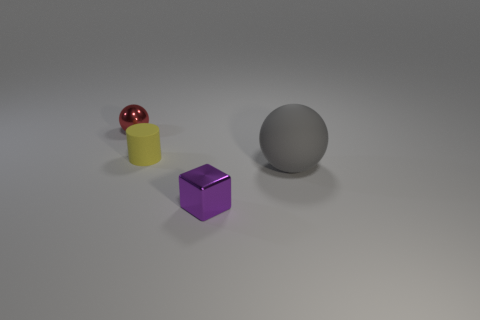What is the color of the metallic ball that is the same size as the yellow matte cylinder?
Your answer should be very brief. Red. There is a metallic thing in front of the tiny metal object behind the rubber object that is in front of the cylinder; what shape is it?
Offer a very short reply. Cube. How many tiny rubber objects are behind the ball that is behind the large gray rubber object?
Provide a succinct answer. 0. There is a tiny shiny thing in front of the red shiny ball; is its shape the same as the small metal thing left of the shiny cube?
Your answer should be very brief. No. What number of rubber things are in front of the tiny metallic block?
Offer a terse response. 0. Are the sphere right of the purple cube and the purple object made of the same material?
Ensure brevity in your answer.  No. There is another thing that is the same shape as the tiny red shiny object; what is its color?
Your response must be concise. Gray. What is the shape of the gray rubber object?
Your answer should be very brief. Sphere. How many things are small purple metal things or yellow matte spheres?
Give a very brief answer. 1. There is a thing that is right of the purple metallic thing; is its color the same as the metal object on the left side of the purple object?
Provide a succinct answer. No. 